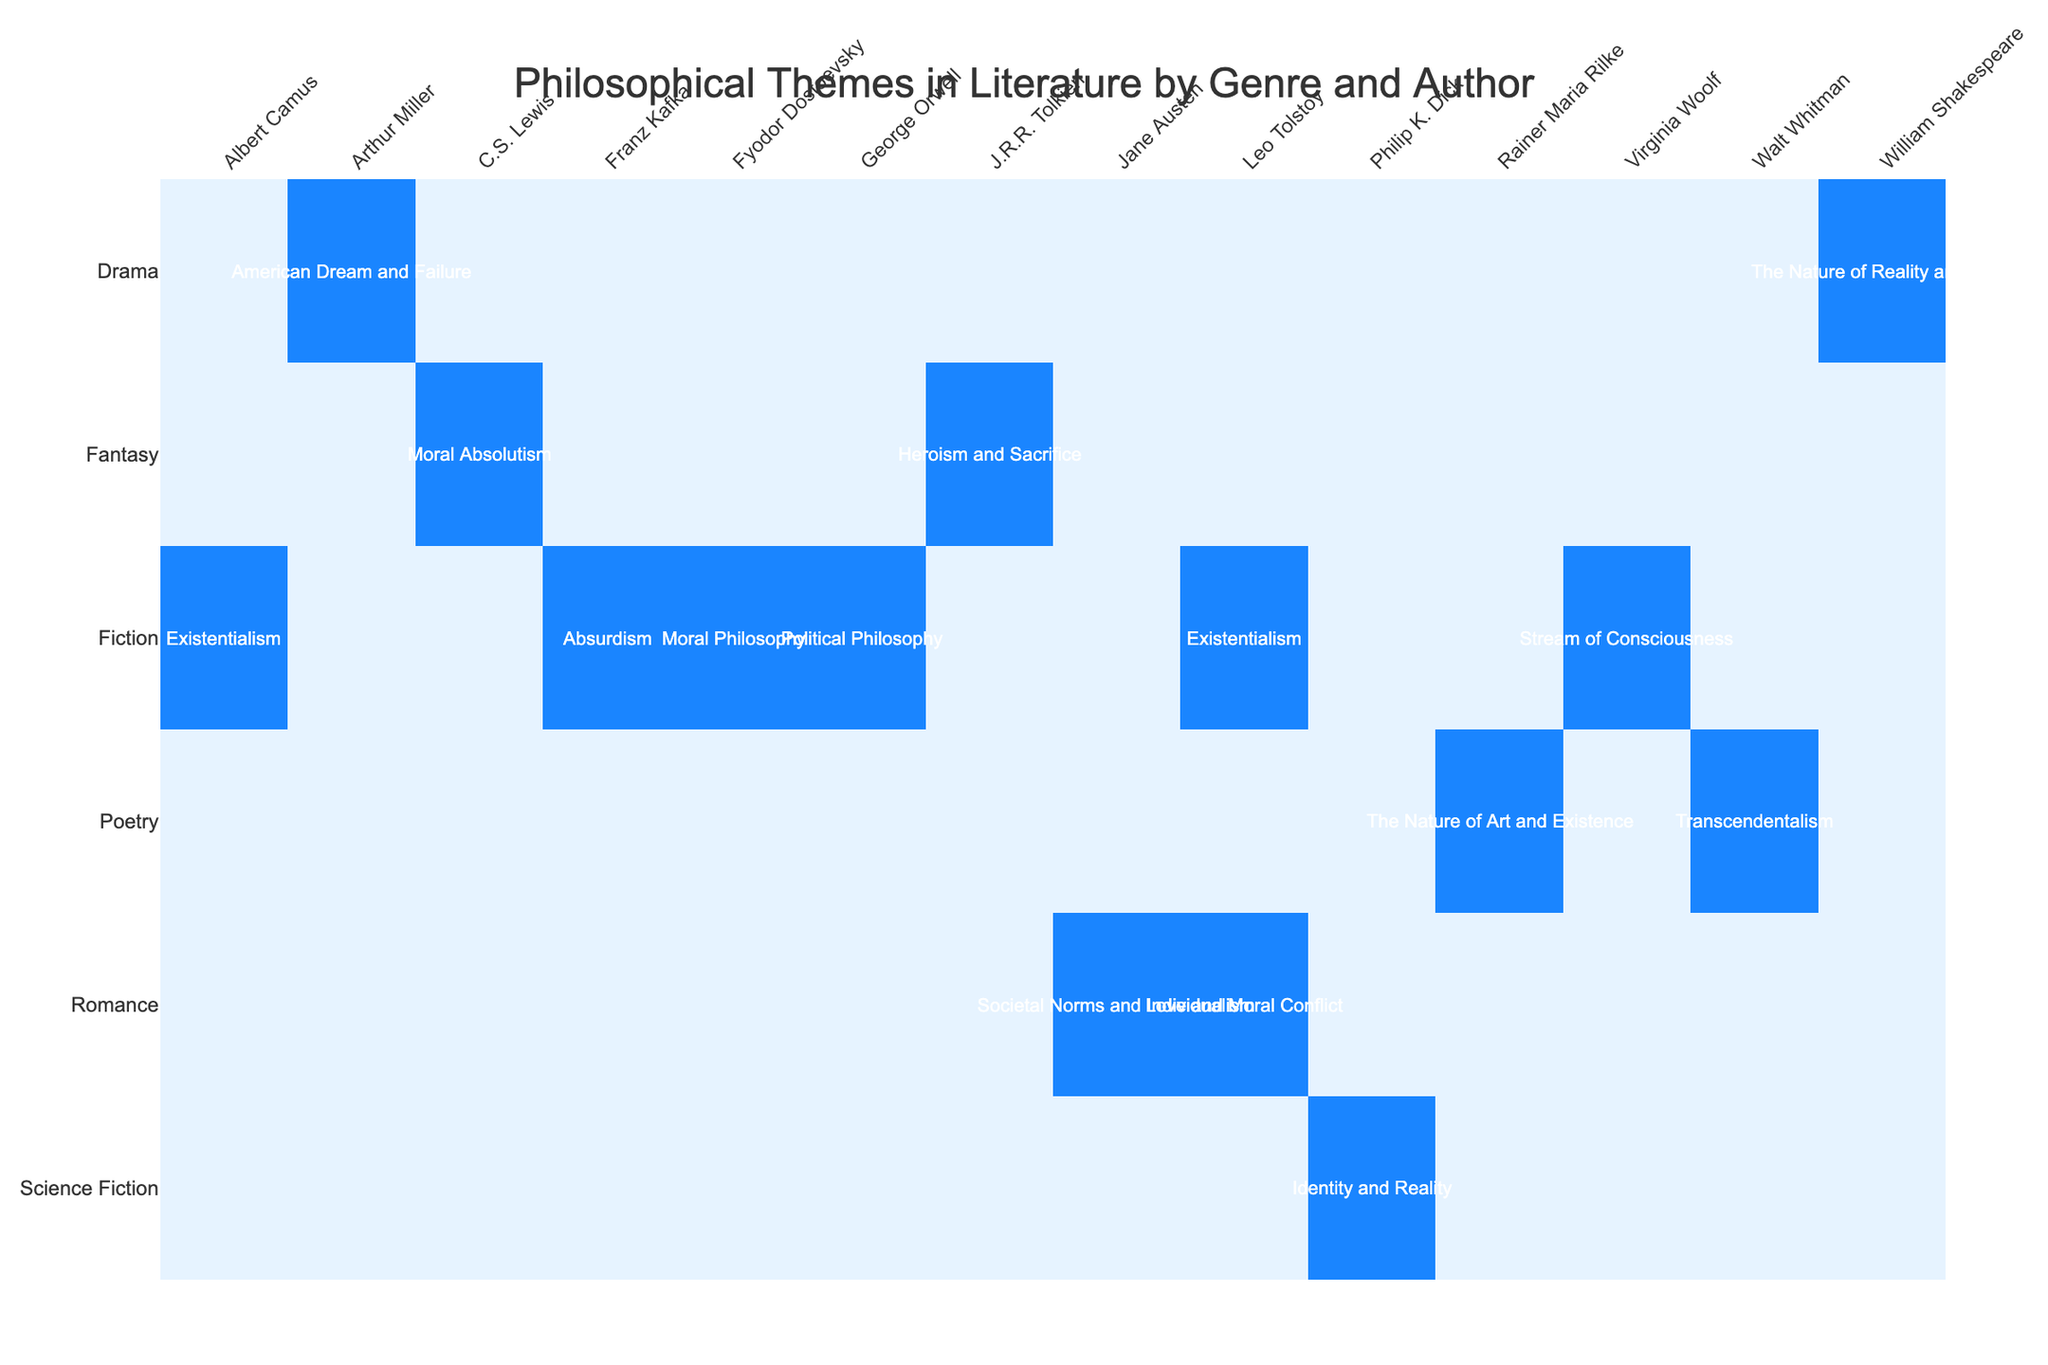What is the philosophical theme of "War and Peace" by Leo Tolstoy? The table indicates that the philosophical theme associated with "War and Peace" by Leo Tolstoy is Existentialism, which can be found in the Fiction genre column under the Author Leo Tolstoy.
Answer: Existentialism Which author is associated with the theme of Absurdism? In the table, the work "The Metamorphosis" by Franz Kafka is associated with the theme of Absurdism, meaning that Franz Kafka is the author linked to this philosophical theme.
Answer: Franz Kafka How many works in the table explore the theme of Moral Philosophy? The table lists only one work, "Crime and Punishment" by Fyodor Dostoevsky, that explores the theme of Moral Philosophy, so the count is one.
Answer: 1 Is there a work by Leo Tolstoy that discusses Love and Moral Conflict? Yes, according to the table, "Anna Karenina" is the work by Leo Tolstoy that addresses the theme of Love and Moral Conflict. This can be verified in the Romance genre section of the table.
Answer: Yes Which genre has the most diverse set of philosophical themes represented by different authors? Analyzing the table, the Fiction genre lists five different authors each with distinct themes: Existentialism, Moral Philosophy, Stream of Consciousness, Absurdism, and Political Philosophy. No other genre contains as many varied themes across different authors.
Answer: Fiction What is the difference between the number of works that address Existentialism and Political Philosophy? The table shows two works addressing Existentialism ("War and Peace" and "The Stranger") and one that addresses Political Philosophy ("1984"). Therefore, the difference is two (Existentialism) minus one (Political Philosophy), which equals one.
Answer: 1 Does "Leaves of Grass" correspond to Transcendentalism? Yes, according to the table, Walt Whitman's "Leaves of Grass" is indeed linked with the philosophical theme of Transcendentalism, confirming that the statement is true.
Answer: Yes Which philosophical themes are discussed in both the Drama and Fiction genres? The only overlapping theme between the Drama and Fiction genres in the table is Moral Philosophy, as exemplified by Fyodor Dostoevsky's "Crime and Punishment" in Fiction and no corresponding work in Drama, confirming that there are no shared works but rather a common theme.
Answer: None How many authors explore the theme of Heroism and Sacrifice? The table shows that J.R.R. Tolkien is the sole author linked to the theme of Heroism and Sacrifice through the work "The Lord of the Rings," leading to a total count of one author.
Answer: 1 